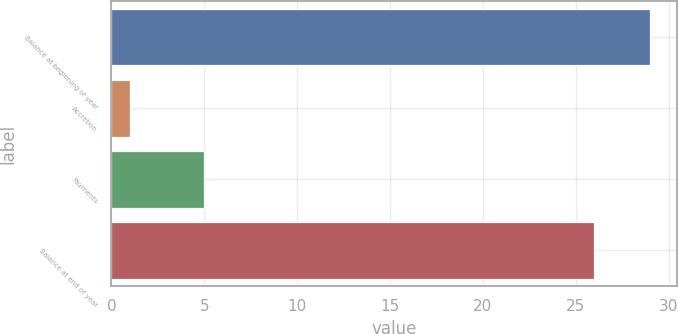Convert chart to OTSL. <chart><loc_0><loc_0><loc_500><loc_500><bar_chart><fcel>Balance at beginning of year<fcel>Accretion<fcel>Payments<fcel>Balance at end of year<nl><fcel>29<fcel>1<fcel>5<fcel>26<nl></chart> 